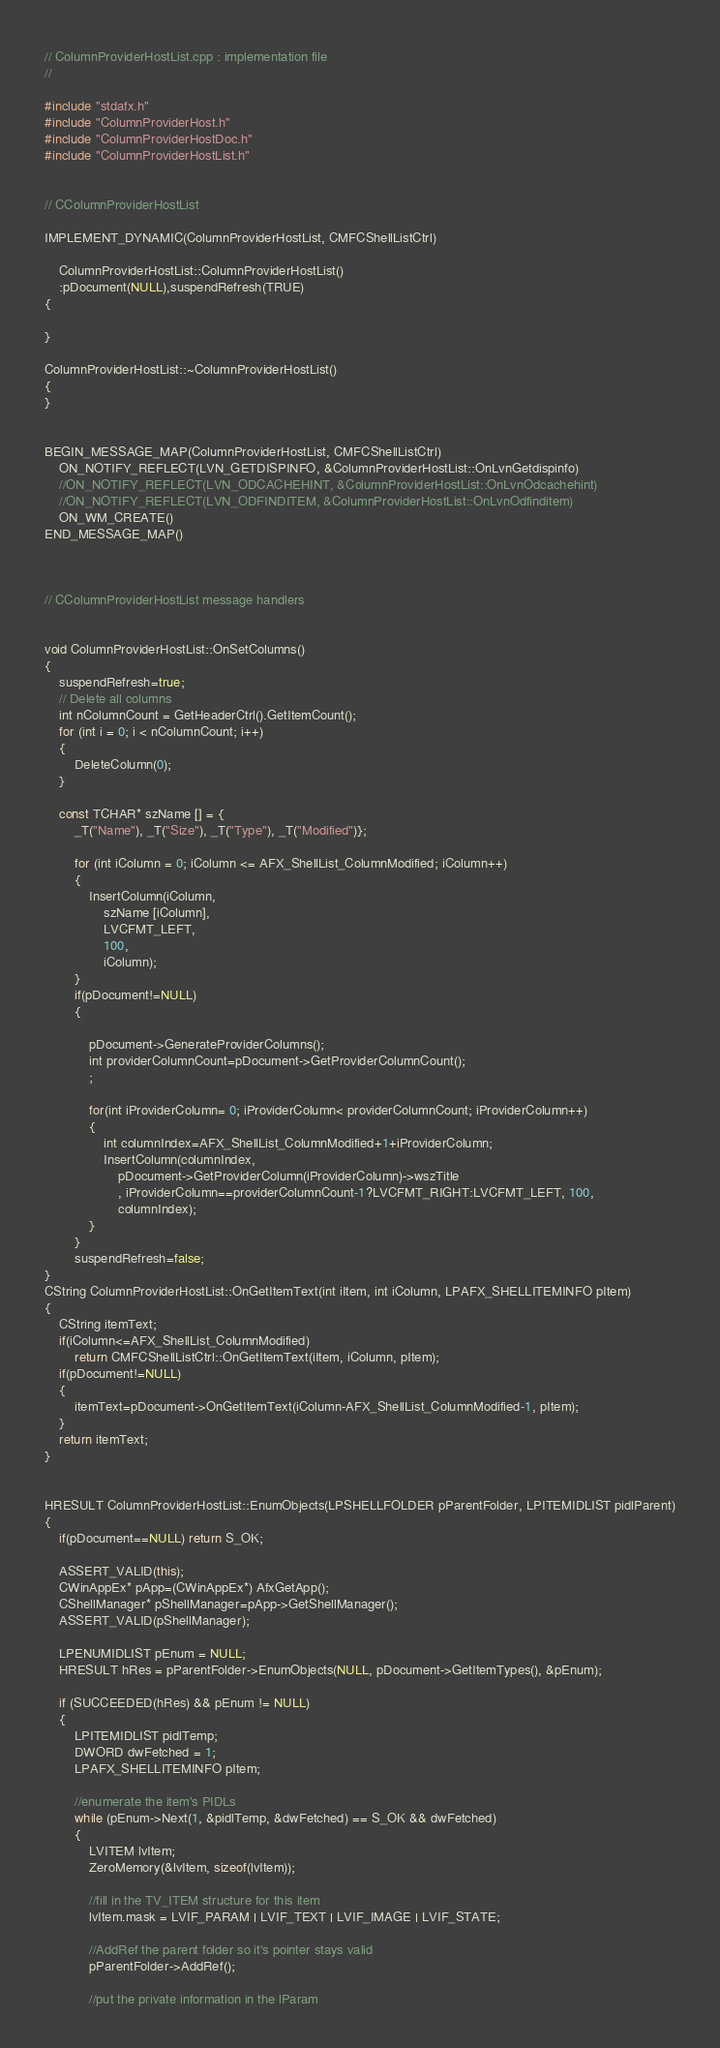Convert code to text. <code><loc_0><loc_0><loc_500><loc_500><_C++_>// ColumnProviderHostList.cpp : implementation file
//

#include "stdafx.h"
#include "ColumnProviderHost.h"
#include "ColumnProviderHostDoc.h"
#include "ColumnProviderHostList.h"


// CColumnProviderHostList

IMPLEMENT_DYNAMIC(ColumnProviderHostList, CMFCShellListCtrl)

	ColumnProviderHostList::ColumnProviderHostList()
	:pDocument(NULL),suspendRefresh(TRUE)
{

}

ColumnProviderHostList::~ColumnProviderHostList()
{
}


BEGIN_MESSAGE_MAP(ColumnProviderHostList, CMFCShellListCtrl)
	ON_NOTIFY_REFLECT(LVN_GETDISPINFO, &ColumnProviderHostList::OnLvnGetdispinfo)
	//ON_NOTIFY_REFLECT(LVN_ODCACHEHINT, &ColumnProviderHostList::OnLvnOdcachehint)
	//ON_NOTIFY_REFLECT(LVN_ODFINDITEM, &ColumnProviderHostList::OnLvnOdfinditem)
	ON_WM_CREATE()
END_MESSAGE_MAP()



// CColumnProviderHostList message handlers


void ColumnProviderHostList::OnSetColumns()
{
	suspendRefresh=true;
	// Delete all columns
	int nColumnCount = GetHeaderCtrl().GetItemCount();
	for (int i = 0; i < nColumnCount; i++)
	{
		DeleteColumn(0);
	}

	const TCHAR* szName [] = {
		_T("Name"), _T("Size"), _T("Type"), _T("Modified")};

		for (int iColumn = 0; iColumn <= AFX_ShellList_ColumnModified; iColumn++)
		{
			InsertColumn(iColumn, 
				szName [iColumn], 
				LVCFMT_LEFT, 
				100, 
				iColumn);
		}
		if(pDocument!=NULL)
		{

			pDocument->GenerateProviderColumns();
			int providerColumnCount=pDocument->GetProviderColumnCount();
			;

			for(int iProviderColumn= 0; iProviderColumn< providerColumnCount; iProviderColumn++)
			{
				int columnIndex=AFX_ShellList_ColumnModified+1+iProviderColumn;
				InsertColumn(columnIndex, 
					pDocument->GetProviderColumn(iProviderColumn)->wszTitle
					, iProviderColumn==providerColumnCount-1?LVCFMT_RIGHT:LVCFMT_LEFT, 100, 
					columnIndex);			
			}		
		}
		suspendRefresh=false;
}
CString ColumnProviderHostList::OnGetItemText(int iItem, int iColumn, LPAFX_SHELLITEMINFO pItem)
{
	CString itemText;
	if(iColumn<=AFX_ShellList_ColumnModified)
		return CMFCShellListCtrl::OnGetItemText(iItem, iColumn, pItem);
	if(pDocument!=NULL)
	{
		itemText=pDocument->OnGetItemText(iColumn-AFX_ShellList_ColumnModified-1, pItem);
	}
	return itemText;
}


HRESULT ColumnProviderHostList::EnumObjects(LPSHELLFOLDER pParentFolder, LPITEMIDLIST pidlParent)
{
	if(pDocument==NULL) return S_OK;

	ASSERT_VALID(this);
	CWinAppEx* pApp=(CWinAppEx*) AfxGetApp();
	CShellManager* pShellManager=pApp->GetShellManager();
	ASSERT_VALID(pShellManager);

	LPENUMIDLIST pEnum = NULL;
	HRESULT hRes = pParentFolder->EnumObjects(NULL, pDocument->GetItemTypes(), &pEnum);

	if (SUCCEEDED(hRes) && pEnum != NULL)
	{
		LPITEMIDLIST pidlTemp;
		DWORD dwFetched = 1;
		LPAFX_SHELLITEMINFO pItem;

		//enumerate the item's PIDLs
		while (pEnum->Next(1, &pidlTemp, &dwFetched) == S_OK && dwFetched)
		{
			LVITEM lvItem;
			ZeroMemory(&lvItem, sizeof(lvItem));

			//fill in the TV_ITEM structure for this item
			lvItem.mask = LVIF_PARAM | LVIF_TEXT | LVIF_IMAGE | LVIF_STATE;

			//AddRef the parent folder so it's pointer stays valid
			pParentFolder->AddRef();

			//put the private information in the lParam</code> 